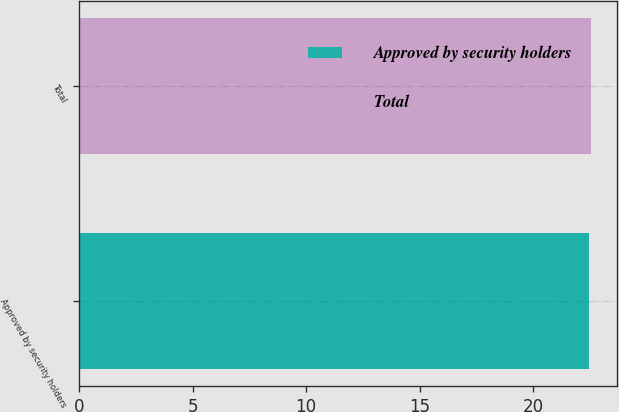Convert chart. <chart><loc_0><loc_0><loc_500><loc_500><bar_chart><fcel>Approved by security holders<fcel>Total<nl><fcel>22.47<fcel>22.57<nl></chart> 